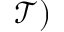<formula> <loc_0><loc_0><loc_500><loc_500>\mathcal { T } )</formula> 